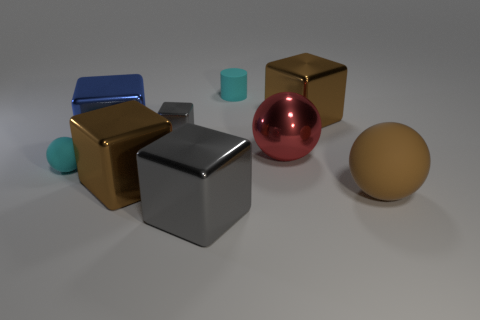There is another large object that is the same shape as the brown rubber thing; what is its material?
Provide a succinct answer. Metal. Is the material of the brown ball the same as the gray cube that is in front of the small matte ball?
Ensure brevity in your answer.  No. Are there an equal number of brown spheres to the left of the small metal block and tiny objects?
Give a very brief answer. No. What is the color of the tiny rubber thing that is behind the red metallic ball?
Your answer should be compact. Cyan. What number of other things are there of the same color as the tiny matte cylinder?
Your answer should be compact. 1. Is there any other thing that has the same size as the brown matte sphere?
Your answer should be very brief. Yes. There is a gray metal object in front of the cyan ball; is its size the same as the big blue cube?
Your response must be concise. Yes. What is the material of the cyan thing that is behind the blue metallic thing?
Provide a succinct answer. Rubber. Is there anything else that is the same shape as the blue shiny thing?
Your answer should be very brief. Yes. What number of matte objects are either cyan cylinders or tiny objects?
Your answer should be compact. 2. 